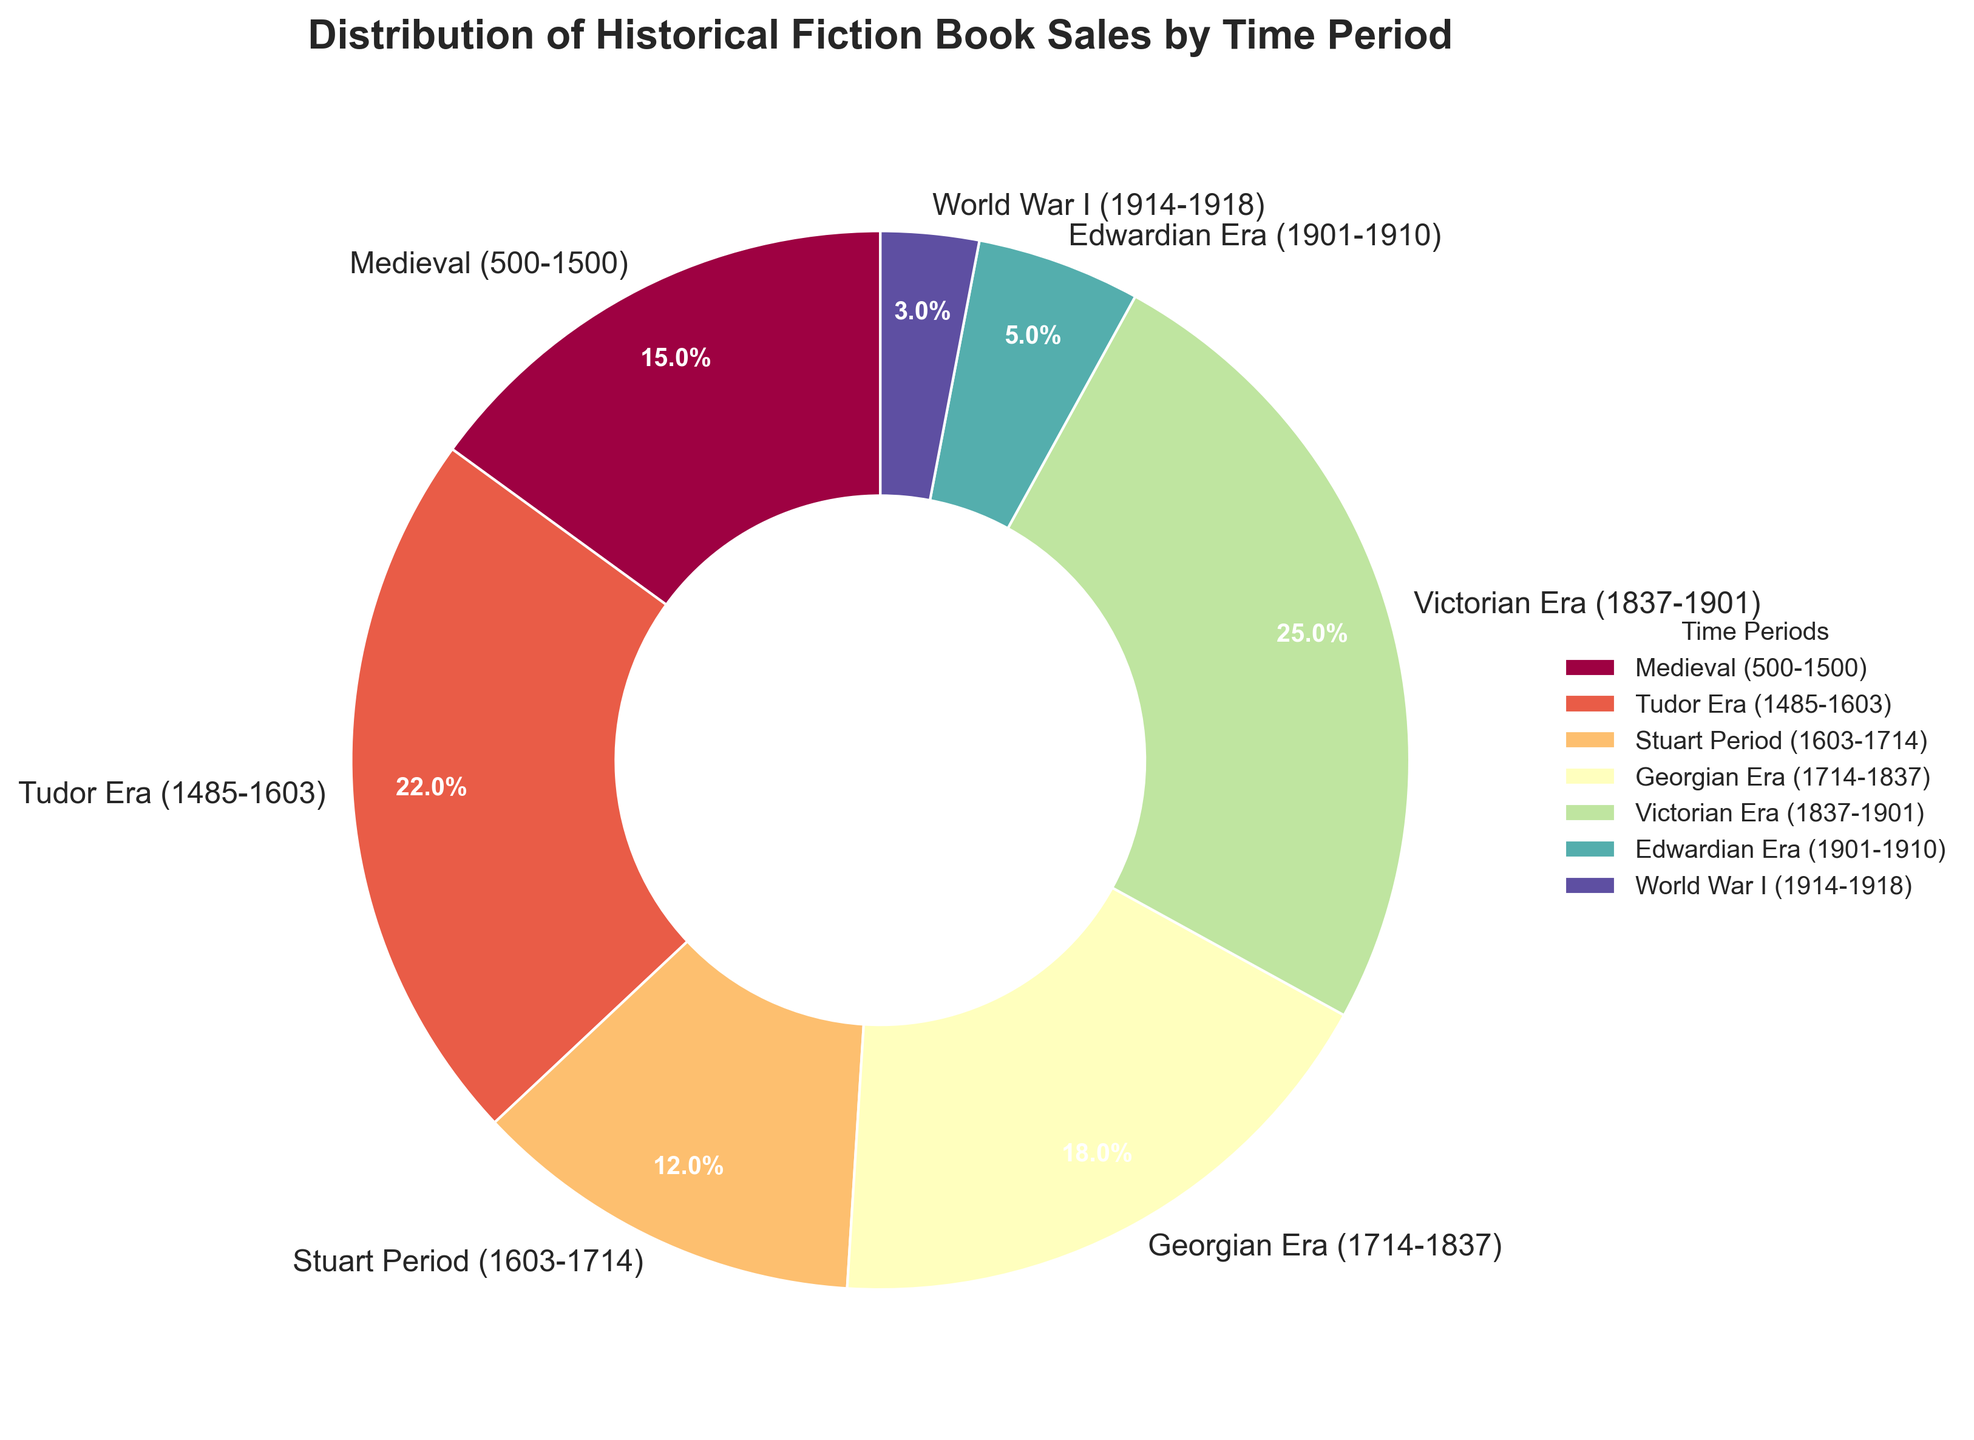What percentage of historical fiction book sales is from the Victorian Era? The figure displays a pie chart where each wedge represents a time period and its corresponding sales percentage. The Victorian Era wedge shows a sales percentage of 25%.
Answer: 25% Which time period has the lowest sales percentage? By inspecting the pie chart, the smallest wedge represents the World War I period, which shows a sales percentage of 3%.
Answer: World War I What is the combined sales percentage of the Medieval and Tudor Eras? The sales percentages for the Medieval Era and Tudor Era are 15% and 22%, respectively. Adding these percentages: 15% + 22% = 37%.
Answer: 37% How does the sales percentage of the Georgian Era compare to the Stuart Period? The pie chart shows the Georgian Era has a sales percentage of 18% and the Stuart Period has 12%. Therefore, the Georgian Era percentage is greater than the Stuart Period percentage.
Answer: Georgian Era has a higher sales percentage Which era's sales percentage is closest to 20%? By examining the pie chart, the Georgian Era's percentage of 18% is closest to 20%.
Answer: Georgian Era Rank the time periods from highest to lowest sales percentage. The percentages are as follows: 
Victorian Era (25%), 
Tudor Era (22%), 
Georgian Era (18%), 
Medieval (15%), 
Stuart Period (12%), 
Edwardian Era (5%), 
World War I (3%).
Answer: Victorian, Tudor, Georgian, Medieval, Stuart, Edwardian, WWI What is the difference in sales percentage between the Victorian Era and the Edwardian Era? The Victorian Era has a sales percentage of 25%, and the Edwardian Era has 5%. The difference is 25% - 5% = 20%.
Answer: 20% What total percentage of sales is accounted for by the three oldest periods (Medieval, Tudor, and Stuart)? Summing the sales percentages: Medieval (15%) + Tudor (22%) + Stuart (12%) = 49%.
Answer: 49% Which time period has a wedge with noticeably bright color? By visual inspection of the color scheme in the pie chart, the Tudor Era wedge appears more brightly colored compared to others, often represented in orange or red.
Answer: Tudor Era 